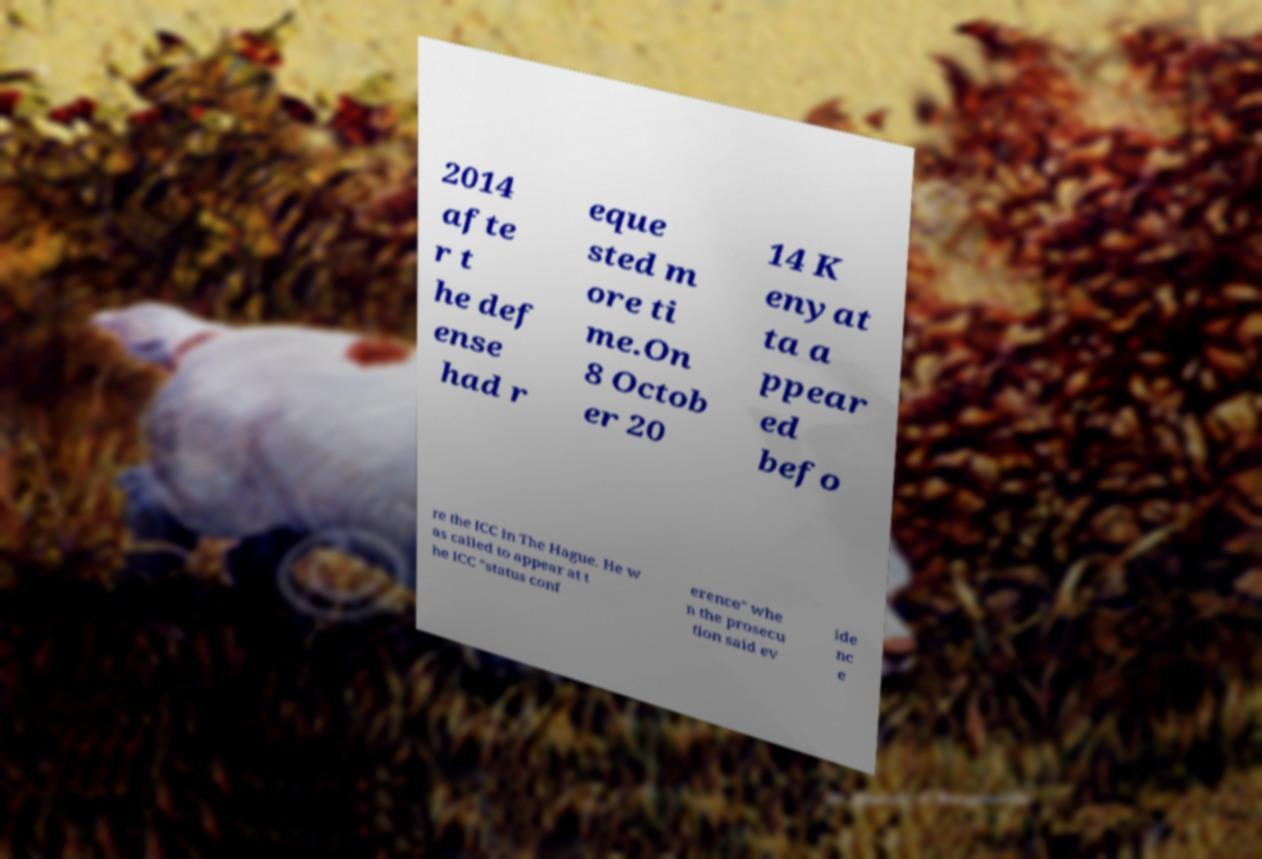Can you accurately transcribe the text from the provided image for me? 2014 afte r t he def ense had r eque sted m ore ti me.On 8 Octob er 20 14 K enyat ta a ppear ed befo re the ICC in The Hague. He w as called to appear at t he ICC "status conf erence" whe n the prosecu tion said ev ide nc e 